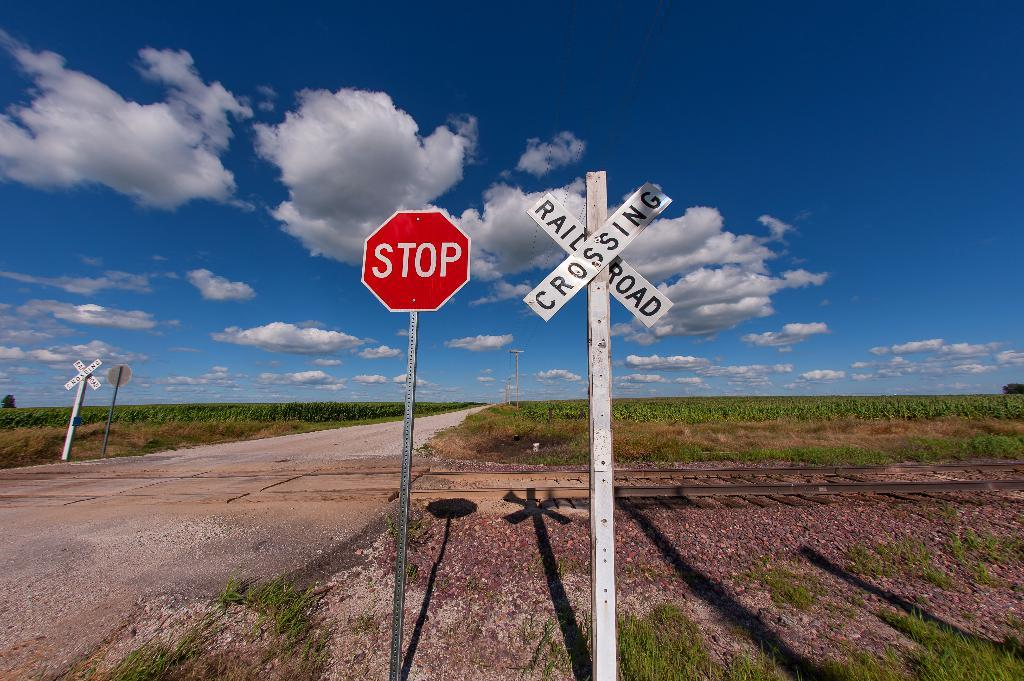<image>
Describe the image concisely. A stop sign stands next to a railroad crossing sign. 